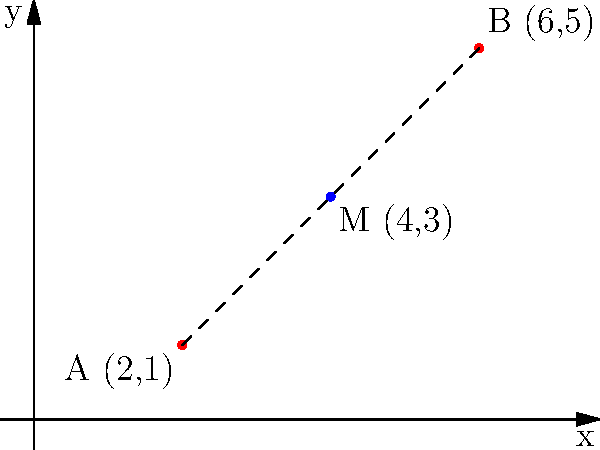Two medical stations, A and B, are located at coordinates (2,1) and (6,5) respectively on a grid map of the shelter complex. To optimize response time, you need to place a supply depot at the midpoint between these two stations. What are the coordinates of this midpoint M? To find the midpoint M between two points A(x₁,y₁) and B(x₂,y₂), we use the midpoint formula:

$$ M = (\frac{x_1 + x_2}{2}, \frac{y_1 + y_2}{2}) $$

Given:
- Point A: (2,1)
- Point B: (6,5)

Step 1: Calculate the x-coordinate of the midpoint:
$$ x_M = \frac{x_1 + x_2}{2} = \frac{2 + 6}{2} = \frac{8}{2} = 4 $$

Step 2: Calculate the y-coordinate of the midpoint:
$$ y_M = \frac{y_1 + y_2}{2} = \frac{1 + 5}{2} = \frac{6}{2} = 3 $$

Step 3: Combine the results to get the midpoint coordinates:
$$ M = (4, 3) $$

Therefore, the supply depot should be placed at coordinates (4,3) to be at the midpoint between the two medical stations.
Answer: (4,3) 